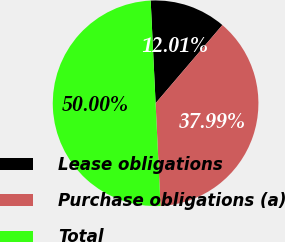Convert chart. <chart><loc_0><loc_0><loc_500><loc_500><pie_chart><fcel>Lease obligations<fcel>Purchase obligations (a)<fcel>Total<nl><fcel>12.01%<fcel>37.99%<fcel>50.0%<nl></chart> 